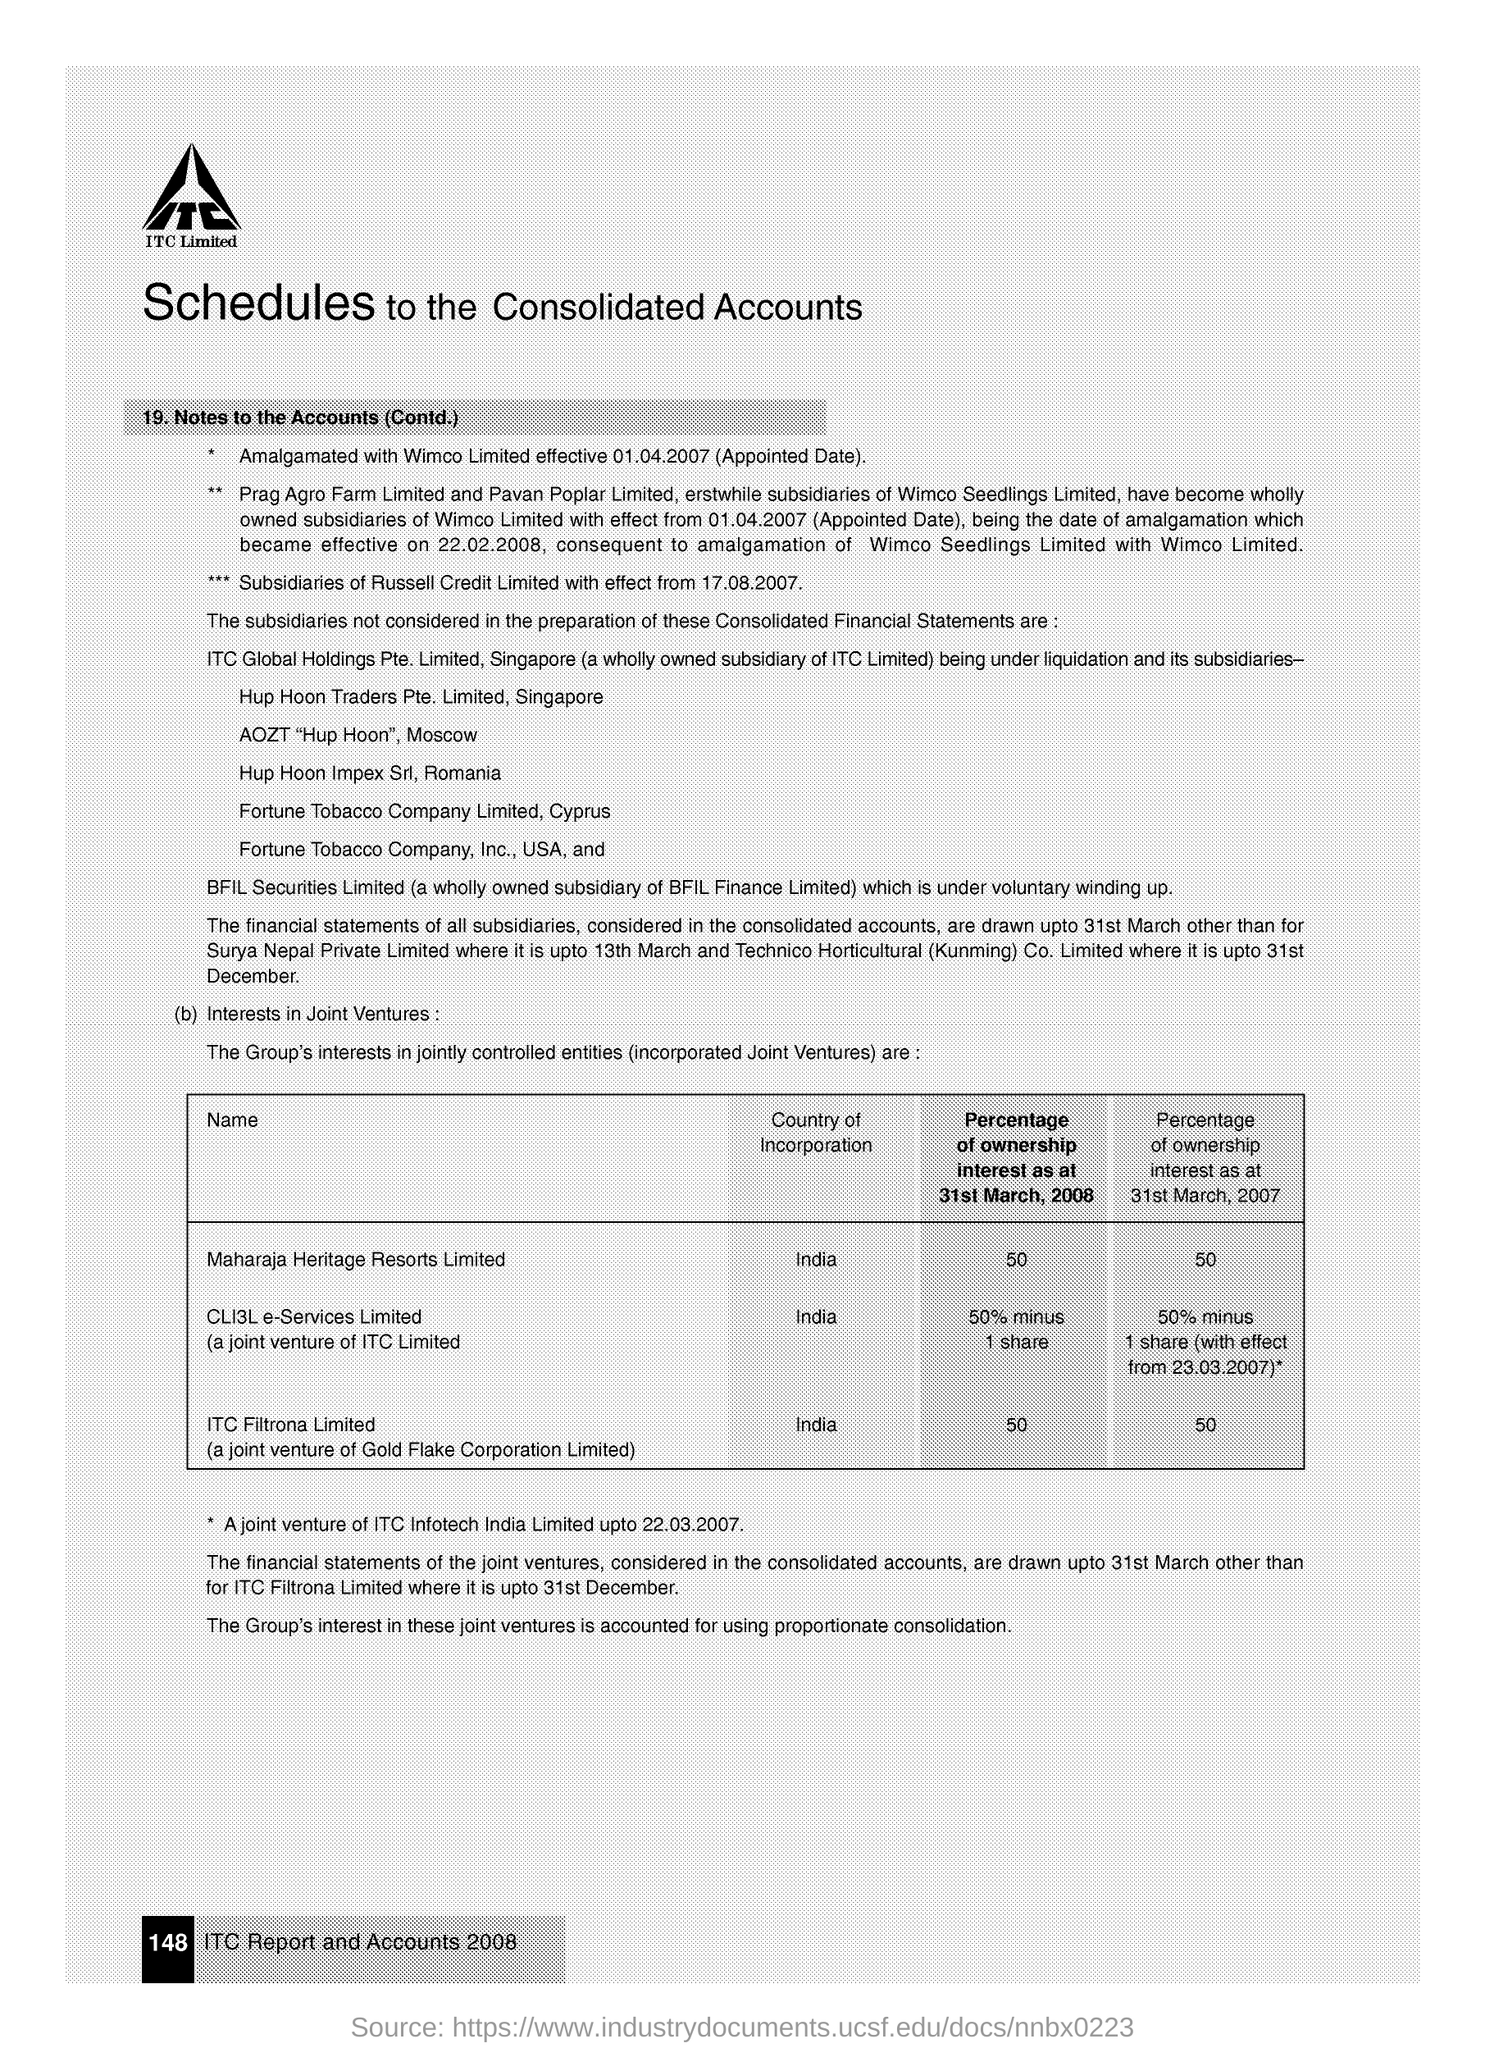What is the country of incorporation of Maharaja Heritage Resorts Limited?
Your response must be concise. India. Which company is a joint venture of gold flake corporation limited?
Offer a terse response. ITC Filtrona Limited. What is the Percentage of ownership interest of Maharaja Heritage Resorts Limited for the year 2008?
Your response must be concise. 50. What is the Percentage of ownership interest of Maharaja Heritage Resorts Limited in the year 2007?
Offer a very short reply. 50. What is the Percentage of ownership interest of ITC Filtrona Limited in the year 2007?
Provide a succinct answer. 50. What is the Percentage of ownership interest of ITC Filtrona Limited in the year 2008?
Provide a succinct answer. 50. 